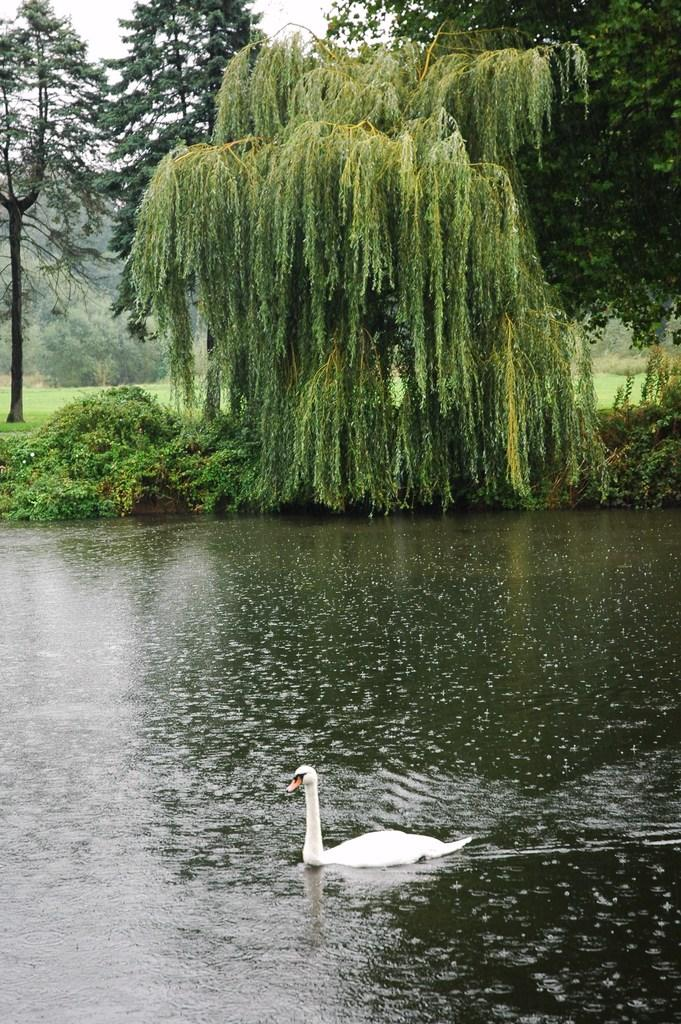What type of body of water is present in the image? There is a lake in the image. What can be seen in the background of the image? There are trees in the image. What animal is present in the water? There is a swan in the water. Where is the uncle in the image? There is no uncle present in the image. What type of needle can be seen in the water? There are no needles present in the image; it features a swan in the water. 